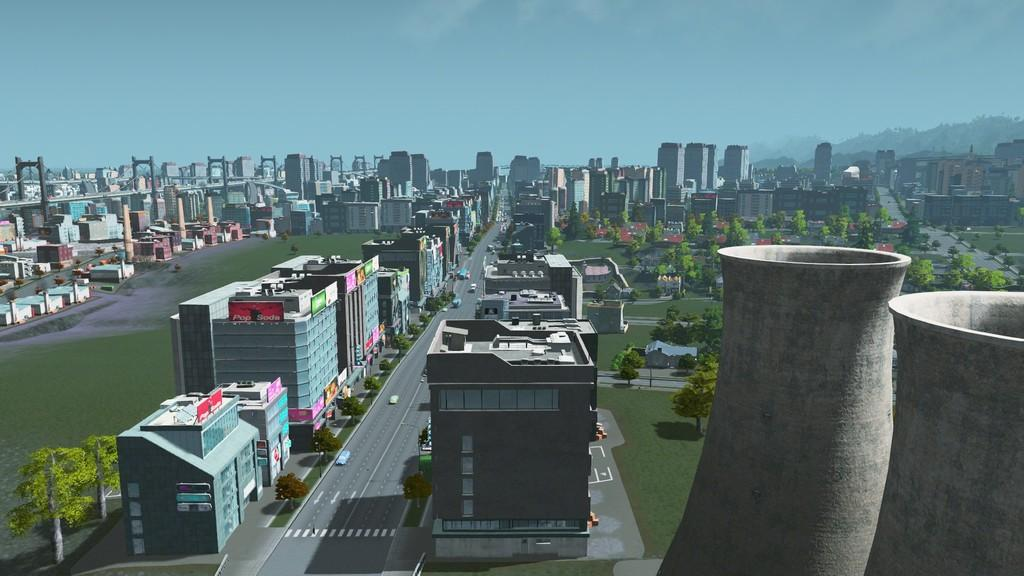What type of image is being described? The image is an animated picture. What structures can be seen in the image? There are buildings in the image. What type of vegetation is present in the image? There are trees in the image. What is visible at the top of the image? The sky is visible at the top of the image. What type of pie is being served in the image? There is no pie present in the image; it is an animated picture with buildings, trees, and a visible sky. Can you tell me how the cord is connected to the buildings in the image? There is no cord present in the image; it features buildings, trees, and a visible sky in an animated setting. 